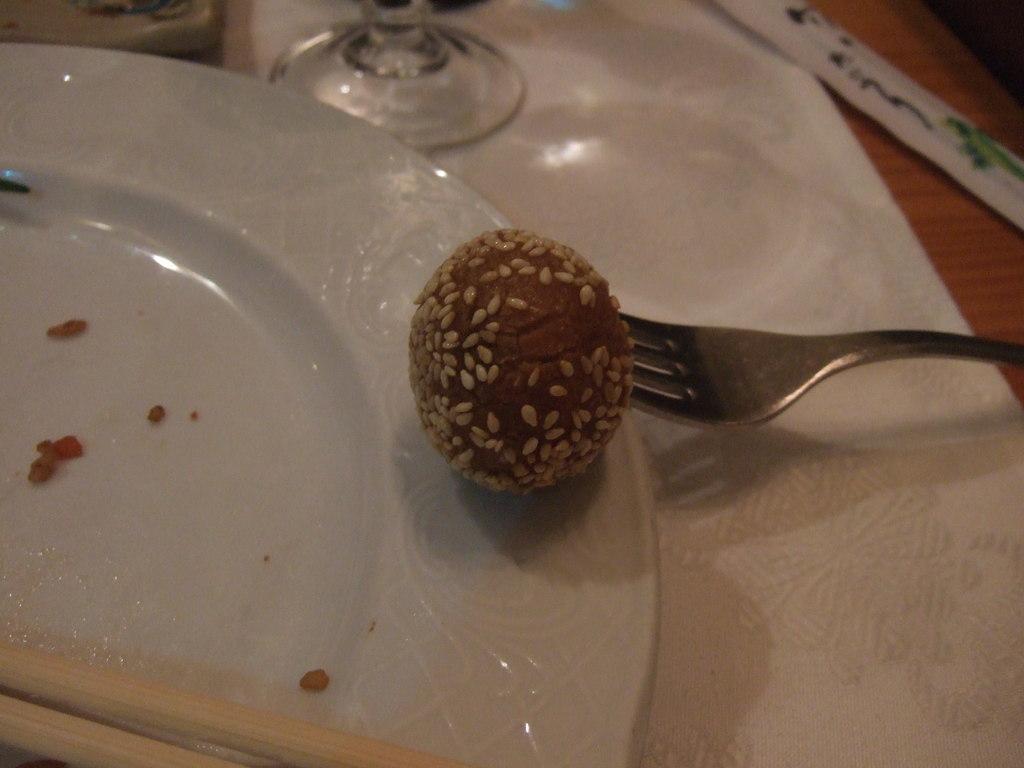Can you describe this image briefly? In this picture, it looks like a table and on the table there is a cloth, plate, a fork, chopsticks, a glass, some objects and a food item and on the food item there are seeds. 